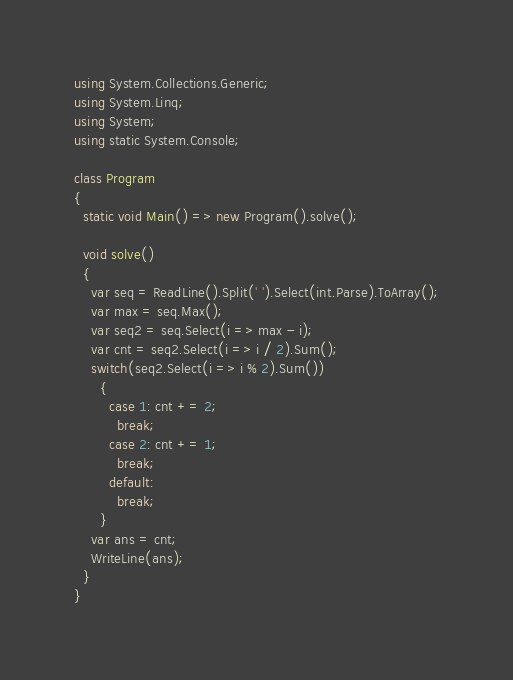<code> <loc_0><loc_0><loc_500><loc_500><_C#_>using System.Collections.Generic;
using System.Linq;
using System;
using static System.Console;

class Program
{
  static void Main() => new Program().solve();

  void solve()
  {
    var seq = ReadLine().Split(' ').Select(int.Parse).ToArray();
    var max = seq.Max();
    var seq2 = seq.Select(i => max - i);
    var cnt = seq2.Select(i => i / 2).Sum();
    switch(seq2.Select(i => i % 2).Sum())
      {
        case 1: cnt += 2;
          break;
        case 2: cnt += 1;
          break;
        default:
          break;
      }
    var ans = cnt;
    WriteLine(ans);
  }
}</code> 